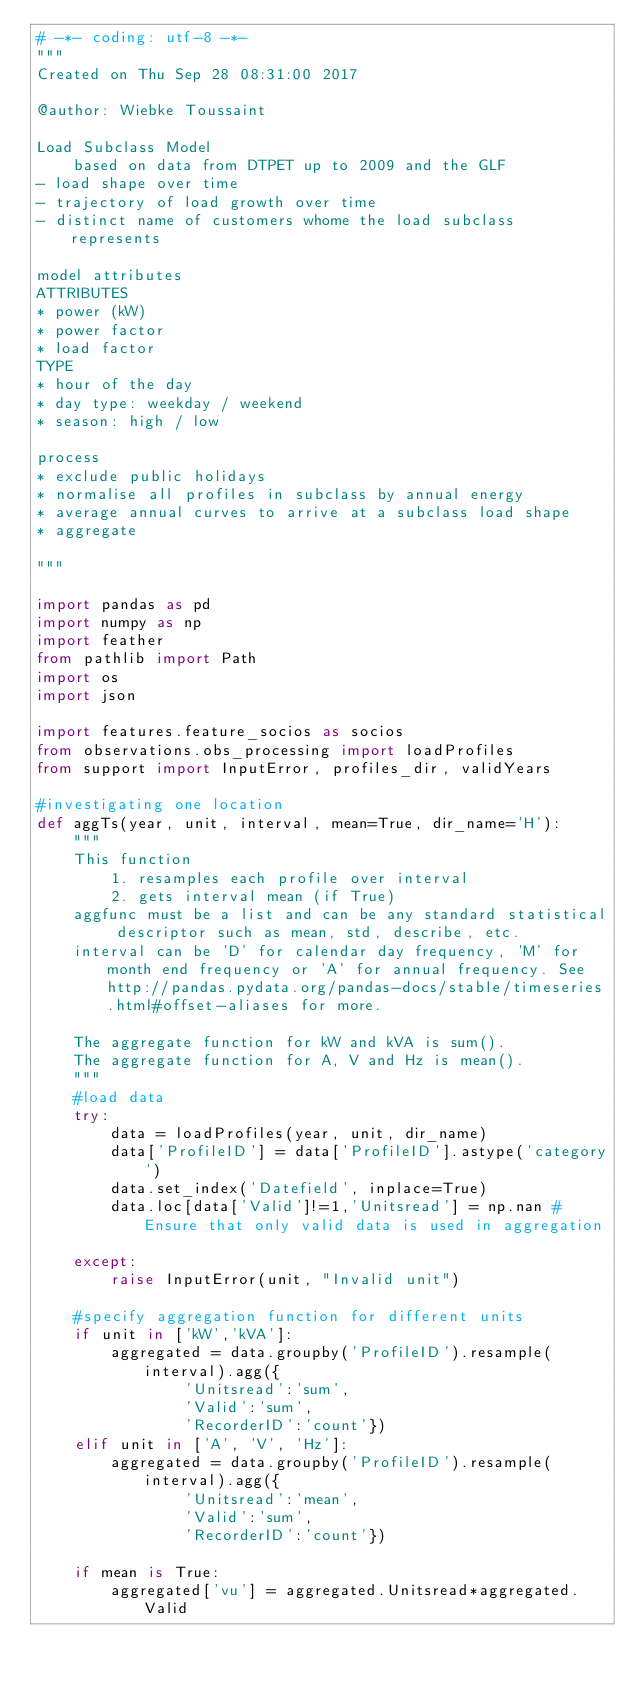Convert code to text. <code><loc_0><loc_0><loc_500><loc_500><_Python_># -*- coding: utf-8 -*-
"""
Created on Thu Sep 28 08:31:00 2017

@author: Wiebke Toussaint

Load Subclass Model
    based on data from DTPET up to 2009 and the GLF 
- load shape over time
- trajectory of load growth over time
- distinct name of customers whome the load subclass represents

model attributes
ATTRIBUTES
* power (kW)
* power factor
* load factor
TYPE
* hour of the day
* day type: weekday / weekend
* season: high / low

process
* exclude public holidays
* normalise all profiles in subclass by annual energy
* average annual curves to arrive at a subclass load shape
* aggregate

"""

import pandas as pd
import numpy as np
import feather
from pathlib import Path
import os
import json

import features.feature_socios as socios
from observations.obs_processing import loadProfiles
from support import InputError, profiles_dir, validYears

#investigating one location
def aggTs(year, unit, interval, mean=True, dir_name='H'):
    """
    This function 
        1. resamples each profile over interval 
        2. gets interval mean (if True)
    aggfunc must be a list and can be any standard statistical descriptor such as mean, std, describe, etc.
    interval can be 'D' for calendar day frequency, 'M' for month end frequency or 'A' for annual frequency. See http://pandas.pydata.org/pandas-docs/stable/timeseries.html#offset-aliases for more.
    
    The aggregate function for kW and kVA is sum().
    The aggregate function for A, V and Hz is mean().
    """
    #load data
    try:
        data = loadProfiles(year, unit, dir_name)
        data['ProfileID'] = data['ProfileID'].astype('category')
        data.set_index('Datefield', inplace=True)
        data.loc[data['Valid']!=1,'Unitsread'] = np.nan #Ensure that only valid data is used in aggregation
        
    except:
        raise InputError(unit, "Invalid unit")      
        
    #specify aggregation function for different units    
    if unit in ['kW','kVA']:
        aggregated = data.groupby('ProfileID').resample(interval).agg({
                'Unitsread':'sum',
                'Valid':'sum',
                'RecorderID':'count'})
    elif unit in ['A', 'V', 'Hz']:
        aggregated = data.groupby('ProfileID').resample(interval).agg({
                'Unitsread':'mean',
                'Valid':'sum',
                'RecorderID':'count'})

    if mean is True:
        aggregated['vu'] = aggregated.Unitsread*aggregated.Valid</code> 